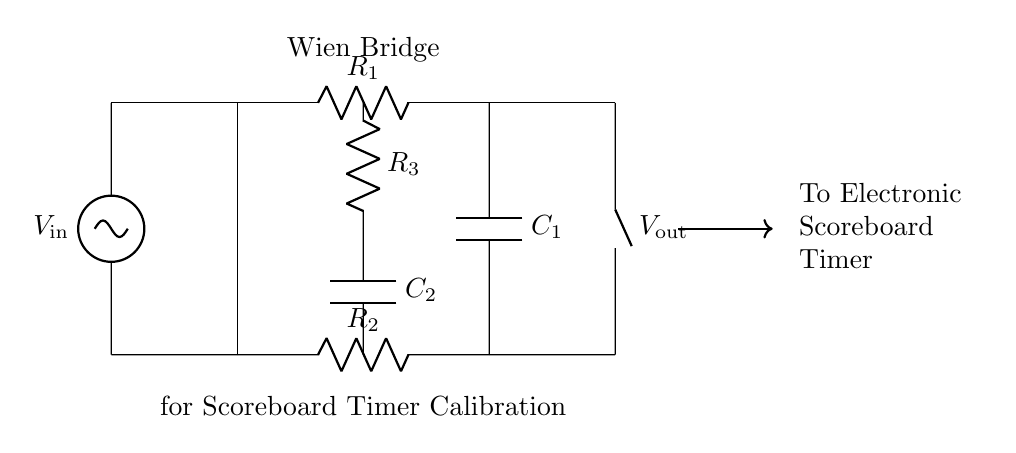What type of circuit is shown? The circuit is a Wien bridge, which is typically used for precise frequency measurements and calibrating instruments. The layout and configuration of the circuit components indicate that it is specifically designed as a Wien bridge circuit.
Answer: Wien bridge What are the labels on the components? The components are labeled as R1, R2, R3 for resistors and C1, C2 for capacitors. These labels indicate the types and roles of the components in the circuit, forming the basis of the Wien bridge configuration.
Answer: R1, R2, R3, C1, C2 What is the function of this circuit? The circuit's function is to calibrate electronic scoreboard timers by providing calibrated output signals based on its configuration and input voltage. The Wien bridge effectively stabilizes the output to ensure accuracy in timing measurements.
Answer: Calibration Which component has the voltage source? The sinusoidal voltage source is located on the left side of the circuit diagram, labeled as Vin. It supplies the input voltage necessary for the Wien bridge to function and generate corresponding output signals.
Answer: Vin What happens to the output when R1 equals R2 and C1 equals C2? When R1 equals R2 and C1 equals C2, the output voltage (Vout) stabilizes, indicating that the circuit is balanced, which is the principle behind the Wien bridge's operation in frequency selection and calibration.
Answer: Stabilizes How does the output connect to the electronic scoreboard? The output (Vout) connects directly to the electronic scoreboard timer via a short line drawn towards the right side of the diagram, illustrating the flow of the calibrated signal from the circuit to the scoreboard.
Answer: Directly 